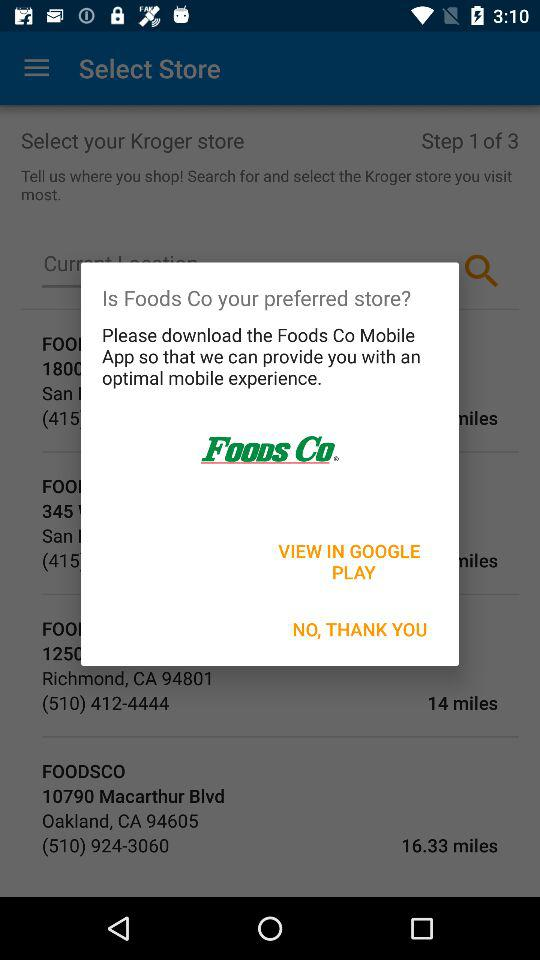What is the address of Foodsco in Oakland? The address is 10790 Macarthur Blvd, Oakland, CA 94605. 